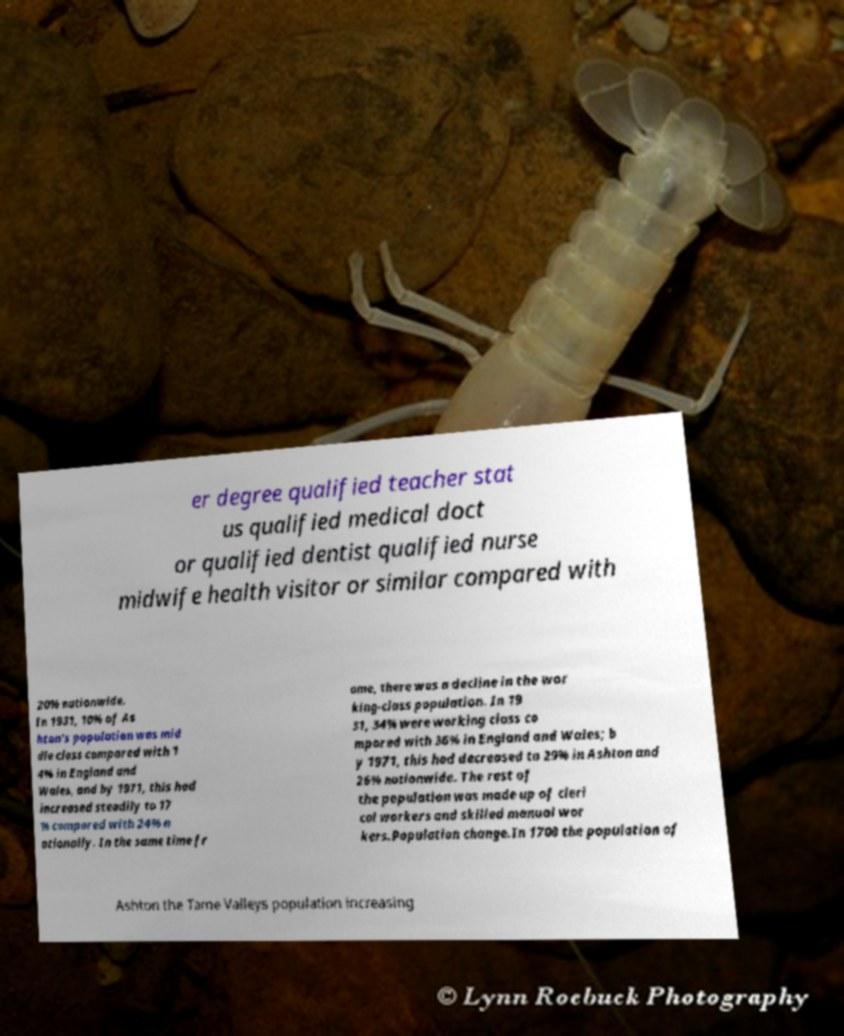Please read and relay the text visible in this image. What does it say? er degree qualified teacher stat us qualified medical doct or qualified dentist qualified nurse midwife health visitor or similar compared with 20% nationwide. In 1931, 10% of As hton's population was mid dle class compared with 1 4% in England and Wales, and by 1971, this had increased steadily to 17 % compared with 24% n ationally. In the same time fr ame, there was a decline in the wor king-class population. In 19 31, 34% were working class co mpared with 36% in England and Wales; b y 1971, this had decreased to 29% in Ashton and 26% nationwide. The rest of the population was made up of cleri cal workers and skilled manual wor kers.Population change.In 1700 the population of Ashton the Tame Valleys population increasing 